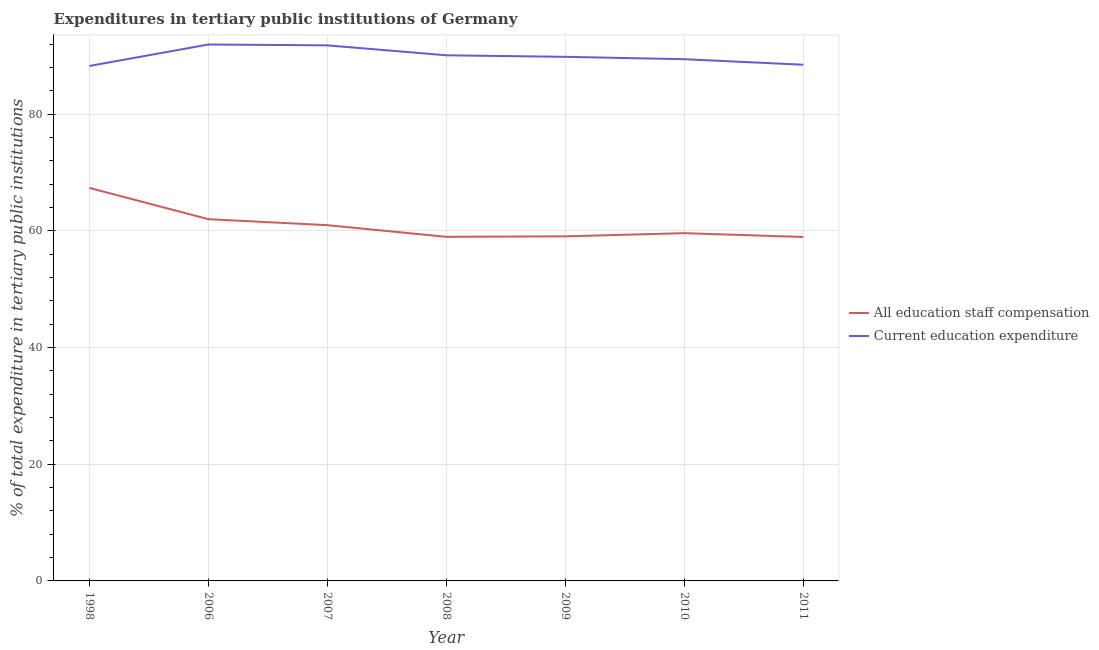Does the line corresponding to expenditure in staff compensation intersect with the line corresponding to expenditure in education?
Your response must be concise. No. Is the number of lines equal to the number of legend labels?
Your answer should be compact. Yes. What is the expenditure in education in 1998?
Make the answer very short. 88.29. Across all years, what is the maximum expenditure in staff compensation?
Give a very brief answer. 67.39. Across all years, what is the minimum expenditure in education?
Give a very brief answer. 88.29. In which year was the expenditure in education maximum?
Your answer should be compact. 2006. In which year was the expenditure in staff compensation minimum?
Offer a terse response. 2011. What is the total expenditure in education in the graph?
Ensure brevity in your answer.  630.03. What is the difference between the expenditure in education in 2006 and that in 2007?
Your answer should be very brief. 0.15. What is the difference between the expenditure in staff compensation in 2007 and the expenditure in education in 2006?
Your answer should be compact. -30.98. What is the average expenditure in staff compensation per year?
Offer a terse response. 61.01. In the year 2007, what is the difference between the expenditure in staff compensation and expenditure in education?
Your response must be concise. -30.83. In how many years, is the expenditure in education greater than 88 %?
Provide a succinct answer. 7. What is the ratio of the expenditure in education in 2006 to that in 2009?
Offer a very short reply. 1.02. Is the difference between the expenditure in staff compensation in 2007 and 2009 greater than the difference between the expenditure in education in 2007 and 2009?
Make the answer very short. No. What is the difference between the highest and the second highest expenditure in education?
Offer a terse response. 0.15. What is the difference between the highest and the lowest expenditure in staff compensation?
Offer a very short reply. 8.42. In how many years, is the expenditure in staff compensation greater than the average expenditure in staff compensation taken over all years?
Offer a terse response. 2. Does the expenditure in education monotonically increase over the years?
Offer a very short reply. No. Is the expenditure in staff compensation strictly greater than the expenditure in education over the years?
Make the answer very short. No. How many years are there in the graph?
Your answer should be very brief. 7. Are the values on the major ticks of Y-axis written in scientific E-notation?
Offer a terse response. No. Does the graph contain any zero values?
Give a very brief answer. No. Does the graph contain grids?
Keep it short and to the point. Yes. How many legend labels are there?
Provide a succinct answer. 2. What is the title of the graph?
Provide a short and direct response. Expenditures in tertiary public institutions of Germany. What is the label or title of the Y-axis?
Your answer should be very brief. % of total expenditure in tertiary public institutions. What is the % of total expenditure in tertiary public institutions in All education staff compensation in 1998?
Ensure brevity in your answer.  67.39. What is the % of total expenditure in tertiary public institutions of Current education expenditure in 1998?
Provide a succinct answer. 88.29. What is the % of total expenditure in tertiary public institutions in All education staff compensation in 2006?
Keep it short and to the point. 62.02. What is the % of total expenditure in tertiary public institutions in Current education expenditure in 2006?
Provide a succinct answer. 91.97. What is the % of total expenditure in tertiary public institutions of All education staff compensation in 2007?
Your answer should be very brief. 61. What is the % of total expenditure in tertiary public institutions of Current education expenditure in 2007?
Your answer should be compact. 91.83. What is the % of total expenditure in tertiary public institutions of All education staff compensation in 2008?
Ensure brevity in your answer.  59. What is the % of total expenditure in tertiary public institutions of Current education expenditure in 2008?
Your answer should be compact. 90.12. What is the % of total expenditure in tertiary public institutions in All education staff compensation in 2009?
Offer a terse response. 59.08. What is the % of total expenditure in tertiary public institutions of Current education expenditure in 2009?
Offer a very short reply. 89.86. What is the % of total expenditure in tertiary public institutions in All education staff compensation in 2010?
Your answer should be very brief. 59.63. What is the % of total expenditure in tertiary public institutions in Current education expenditure in 2010?
Offer a very short reply. 89.45. What is the % of total expenditure in tertiary public institutions of All education staff compensation in 2011?
Offer a terse response. 58.97. What is the % of total expenditure in tertiary public institutions of Current education expenditure in 2011?
Provide a succinct answer. 88.5. Across all years, what is the maximum % of total expenditure in tertiary public institutions in All education staff compensation?
Your answer should be very brief. 67.39. Across all years, what is the maximum % of total expenditure in tertiary public institutions of Current education expenditure?
Give a very brief answer. 91.97. Across all years, what is the minimum % of total expenditure in tertiary public institutions in All education staff compensation?
Your response must be concise. 58.97. Across all years, what is the minimum % of total expenditure in tertiary public institutions in Current education expenditure?
Offer a terse response. 88.29. What is the total % of total expenditure in tertiary public institutions of All education staff compensation in the graph?
Your response must be concise. 427.09. What is the total % of total expenditure in tertiary public institutions in Current education expenditure in the graph?
Your response must be concise. 630.03. What is the difference between the % of total expenditure in tertiary public institutions in All education staff compensation in 1998 and that in 2006?
Your response must be concise. 5.36. What is the difference between the % of total expenditure in tertiary public institutions in Current education expenditure in 1998 and that in 2006?
Offer a terse response. -3.68. What is the difference between the % of total expenditure in tertiary public institutions in All education staff compensation in 1998 and that in 2007?
Offer a terse response. 6.39. What is the difference between the % of total expenditure in tertiary public institutions in Current education expenditure in 1998 and that in 2007?
Make the answer very short. -3.53. What is the difference between the % of total expenditure in tertiary public institutions of All education staff compensation in 1998 and that in 2008?
Offer a terse response. 8.39. What is the difference between the % of total expenditure in tertiary public institutions in Current education expenditure in 1998 and that in 2008?
Keep it short and to the point. -1.83. What is the difference between the % of total expenditure in tertiary public institutions of All education staff compensation in 1998 and that in 2009?
Offer a terse response. 8.31. What is the difference between the % of total expenditure in tertiary public institutions of Current education expenditure in 1998 and that in 2009?
Your answer should be compact. -1.57. What is the difference between the % of total expenditure in tertiary public institutions of All education staff compensation in 1998 and that in 2010?
Make the answer very short. 7.76. What is the difference between the % of total expenditure in tertiary public institutions of Current education expenditure in 1998 and that in 2010?
Make the answer very short. -1.16. What is the difference between the % of total expenditure in tertiary public institutions of All education staff compensation in 1998 and that in 2011?
Offer a very short reply. 8.42. What is the difference between the % of total expenditure in tertiary public institutions in Current education expenditure in 1998 and that in 2011?
Your answer should be very brief. -0.21. What is the difference between the % of total expenditure in tertiary public institutions of All education staff compensation in 2006 and that in 2007?
Your response must be concise. 1.03. What is the difference between the % of total expenditure in tertiary public institutions of Current education expenditure in 2006 and that in 2007?
Give a very brief answer. 0.15. What is the difference between the % of total expenditure in tertiary public institutions of All education staff compensation in 2006 and that in 2008?
Your answer should be very brief. 3.03. What is the difference between the % of total expenditure in tertiary public institutions of Current education expenditure in 2006 and that in 2008?
Make the answer very short. 1.85. What is the difference between the % of total expenditure in tertiary public institutions in All education staff compensation in 2006 and that in 2009?
Offer a terse response. 2.94. What is the difference between the % of total expenditure in tertiary public institutions of Current education expenditure in 2006 and that in 2009?
Offer a very short reply. 2.11. What is the difference between the % of total expenditure in tertiary public institutions of All education staff compensation in 2006 and that in 2010?
Offer a very short reply. 2.4. What is the difference between the % of total expenditure in tertiary public institutions in Current education expenditure in 2006 and that in 2010?
Your response must be concise. 2.52. What is the difference between the % of total expenditure in tertiary public institutions of All education staff compensation in 2006 and that in 2011?
Provide a short and direct response. 3.05. What is the difference between the % of total expenditure in tertiary public institutions of Current education expenditure in 2006 and that in 2011?
Your answer should be very brief. 3.47. What is the difference between the % of total expenditure in tertiary public institutions in All education staff compensation in 2007 and that in 2008?
Offer a very short reply. 2. What is the difference between the % of total expenditure in tertiary public institutions in Current education expenditure in 2007 and that in 2008?
Offer a terse response. 1.7. What is the difference between the % of total expenditure in tertiary public institutions in All education staff compensation in 2007 and that in 2009?
Your response must be concise. 1.92. What is the difference between the % of total expenditure in tertiary public institutions in Current education expenditure in 2007 and that in 2009?
Keep it short and to the point. 1.97. What is the difference between the % of total expenditure in tertiary public institutions of All education staff compensation in 2007 and that in 2010?
Provide a short and direct response. 1.37. What is the difference between the % of total expenditure in tertiary public institutions of Current education expenditure in 2007 and that in 2010?
Provide a succinct answer. 2.37. What is the difference between the % of total expenditure in tertiary public institutions of All education staff compensation in 2007 and that in 2011?
Your answer should be very brief. 2.03. What is the difference between the % of total expenditure in tertiary public institutions of Current education expenditure in 2007 and that in 2011?
Your answer should be compact. 3.32. What is the difference between the % of total expenditure in tertiary public institutions in All education staff compensation in 2008 and that in 2009?
Provide a succinct answer. -0.08. What is the difference between the % of total expenditure in tertiary public institutions in Current education expenditure in 2008 and that in 2009?
Offer a terse response. 0.26. What is the difference between the % of total expenditure in tertiary public institutions of All education staff compensation in 2008 and that in 2010?
Keep it short and to the point. -0.63. What is the difference between the % of total expenditure in tertiary public institutions of Current education expenditure in 2008 and that in 2010?
Your answer should be very brief. 0.67. What is the difference between the % of total expenditure in tertiary public institutions in All education staff compensation in 2008 and that in 2011?
Make the answer very short. 0.03. What is the difference between the % of total expenditure in tertiary public institutions of Current education expenditure in 2008 and that in 2011?
Give a very brief answer. 1.62. What is the difference between the % of total expenditure in tertiary public institutions in All education staff compensation in 2009 and that in 2010?
Give a very brief answer. -0.54. What is the difference between the % of total expenditure in tertiary public institutions in Current education expenditure in 2009 and that in 2010?
Provide a short and direct response. 0.41. What is the difference between the % of total expenditure in tertiary public institutions in All education staff compensation in 2009 and that in 2011?
Provide a short and direct response. 0.11. What is the difference between the % of total expenditure in tertiary public institutions of Current education expenditure in 2009 and that in 2011?
Make the answer very short. 1.36. What is the difference between the % of total expenditure in tertiary public institutions in All education staff compensation in 2010 and that in 2011?
Offer a very short reply. 0.65. What is the difference between the % of total expenditure in tertiary public institutions in Current education expenditure in 2010 and that in 2011?
Provide a short and direct response. 0.95. What is the difference between the % of total expenditure in tertiary public institutions of All education staff compensation in 1998 and the % of total expenditure in tertiary public institutions of Current education expenditure in 2006?
Your answer should be compact. -24.58. What is the difference between the % of total expenditure in tertiary public institutions in All education staff compensation in 1998 and the % of total expenditure in tertiary public institutions in Current education expenditure in 2007?
Your answer should be very brief. -24.44. What is the difference between the % of total expenditure in tertiary public institutions of All education staff compensation in 1998 and the % of total expenditure in tertiary public institutions of Current education expenditure in 2008?
Your response must be concise. -22.73. What is the difference between the % of total expenditure in tertiary public institutions of All education staff compensation in 1998 and the % of total expenditure in tertiary public institutions of Current education expenditure in 2009?
Offer a very short reply. -22.47. What is the difference between the % of total expenditure in tertiary public institutions in All education staff compensation in 1998 and the % of total expenditure in tertiary public institutions in Current education expenditure in 2010?
Offer a very short reply. -22.06. What is the difference between the % of total expenditure in tertiary public institutions in All education staff compensation in 1998 and the % of total expenditure in tertiary public institutions in Current education expenditure in 2011?
Provide a succinct answer. -21.11. What is the difference between the % of total expenditure in tertiary public institutions of All education staff compensation in 2006 and the % of total expenditure in tertiary public institutions of Current education expenditure in 2007?
Give a very brief answer. -29.8. What is the difference between the % of total expenditure in tertiary public institutions in All education staff compensation in 2006 and the % of total expenditure in tertiary public institutions in Current education expenditure in 2008?
Make the answer very short. -28.1. What is the difference between the % of total expenditure in tertiary public institutions of All education staff compensation in 2006 and the % of total expenditure in tertiary public institutions of Current education expenditure in 2009?
Ensure brevity in your answer.  -27.83. What is the difference between the % of total expenditure in tertiary public institutions of All education staff compensation in 2006 and the % of total expenditure in tertiary public institutions of Current education expenditure in 2010?
Provide a succinct answer. -27.43. What is the difference between the % of total expenditure in tertiary public institutions in All education staff compensation in 2006 and the % of total expenditure in tertiary public institutions in Current education expenditure in 2011?
Make the answer very short. -26.48. What is the difference between the % of total expenditure in tertiary public institutions in All education staff compensation in 2007 and the % of total expenditure in tertiary public institutions in Current education expenditure in 2008?
Keep it short and to the point. -29.13. What is the difference between the % of total expenditure in tertiary public institutions in All education staff compensation in 2007 and the % of total expenditure in tertiary public institutions in Current education expenditure in 2009?
Your answer should be very brief. -28.86. What is the difference between the % of total expenditure in tertiary public institutions of All education staff compensation in 2007 and the % of total expenditure in tertiary public institutions of Current education expenditure in 2010?
Provide a short and direct response. -28.46. What is the difference between the % of total expenditure in tertiary public institutions of All education staff compensation in 2007 and the % of total expenditure in tertiary public institutions of Current education expenditure in 2011?
Your answer should be compact. -27.51. What is the difference between the % of total expenditure in tertiary public institutions of All education staff compensation in 2008 and the % of total expenditure in tertiary public institutions of Current education expenditure in 2009?
Make the answer very short. -30.86. What is the difference between the % of total expenditure in tertiary public institutions in All education staff compensation in 2008 and the % of total expenditure in tertiary public institutions in Current education expenditure in 2010?
Keep it short and to the point. -30.45. What is the difference between the % of total expenditure in tertiary public institutions of All education staff compensation in 2008 and the % of total expenditure in tertiary public institutions of Current education expenditure in 2011?
Your response must be concise. -29.5. What is the difference between the % of total expenditure in tertiary public institutions of All education staff compensation in 2009 and the % of total expenditure in tertiary public institutions of Current education expenditure in 2010?
Your response must be concise. -30.37. What is the difference between the % of total expenditure in tertiary public institutions in All education staff compensation in 2009 and the % of total expenditure in tertiary public institutions in Current education expenditure in 2011?
Ensure brevity in your answer.  -29.42. What is the difference between the % of total expenditure in tertiary public institutions in All education staff compensation in 2010 and the % of total expenditure in tertiary public institutions in Current education expenditure in 2011?
Ensure brevity in your answer.  -28.88. What is the average % of total expenditure in tertiary public institutions in All education staff compensation per year?
Your response must be concise. 61.01. What is the average % of total expenditure in tertiary public institutions of Current education expenditure per year?
Provide a succinct answer. 90. In the year 1998, what is the difference between the % of total expenditure in tertiary public institutions in All education staff compensation and % of total expenditure in tertiary public institutions in Current education expenditure?
Ensure brevity in your answer.  -20.9. In the year 2006, what is the difference between the % of total expenditure in tertiary public institutions of All education staff compensation and % of total expenditure in tertiary public institutions of Current education expenditure?
Your answer should be compact. -29.95. In the year 2007, what is the difference between the % of total expenditure in tertiary public institutions of All education staff compensation and % of total expenditure in tertiary public institutions of Current education expenditure?
Provide a short and direct response. -30.83. In the year 2008, what is the difference between the % of total expenditure in tertiary public institutions in All education staff compensation and % of total expenditure in tertiary public institutions in Current education expenditure?
Keep it short and to the point. -31.12. In the year 2009, what is the difference between the % of total expenditure in tertiary public institutions of All education staff compensation and % of total expenditure in tertiary public institutions of Current education expenditure?
Ensure brevity in your answer.  -30.78. In the year 2010, what is the difference between the % of total expenditure in tertiary public institutions in All education staff compensation and % of total expenditure in tertiary public institutions in Current education expenditure?
Provide a succinct answer. -29.83. In the year 2011, what is the difference between the % of total expenditure in tertiary public institutions in All education staff compensation and % of total expenditure in tertiary public institutions in Current education expenditure?
Offer a terse response. -29.53. What is the ratio of the % of total expenditure in tertiary public institutions of All education staff compensation in 1998 to that in 2006?
Keep it short and to the point. 1.09. What is the ratio of the % of total expenditure in tertiary public institutions of Current education expenditure in 1998 to that in 2006?
Your answer should be very brief. 0.96. What is the ratio of the % of total expenditure in tertiary public institutions in All education staff compensation in 1998 to that in 2007?
Make the answer very short. 1.1. What is the ratio of the % of total expenditure in tertiary public institutions of Current education expenditure in 1998 to that in 2007?
Make the answer very short. 0.96. What is the ratio of the % of total expenditure in tertiary public institutions in All education staff compensation in 1998 to that in 2008?
Provide a short and direct response. 1.14. What is the ratio of the % of total expenditure in tertiary public institutions in Current education expenditure in 1998 to that in 2008?
Your answer should be very brief. 0.98. What is the ratio of the % of total expenditure in tertiary public institutions in All education staff compensation in 1998 to that in 2009?
Make the answer very short. 1.14. What is the ratio of the % of total expenditure in tertiary public institutions of Current education expenditure in 1998 to that in 2009?
Your answer should be compact. 0.98. What is the ratio of the % of total expenditure in tertiary public institutions in All education staff compensation in 1998 to that in 2010?
Ensure brevity in your answer.  1.13. What is the ratio of the % of total expenditure in tertiary public institutions of Current education expenditure in 1998 to that in 2010?
Your answer should be compact. 0.99. What is the ratio of the % of total expenditure in tertiary public institutions in All education staff compensation in 1998 to that in 2011?
Provide a short and direct response. 1.14. What is the ratio of the % of total expenditure in tertiary public institutions in All education staff compensation in 2006 to that in 2007?
Offer a terse response. 1.02. What is the ratio of the % of total expenditure in tertiary public institutions in Current education expenditure in 2006 to that in 2007?
Ensure brevity in your answer.  1. What is the ratio of the % of total expenditure in tertiary public institutions in All education staff compensation in 2006 to that in 2008?
Ensure brevity in your answer.  1.05. What is the ratio of the % of total expenditure in tertiary public institutions of Current education expenditure in 2006 to that in 2008?
Your answer should be compact. 1.02. What is the ratio of the % of total expenditure in tertiary public institutions in All education staff compensation in 2006 to that in 2009?
Provide a short and direct response. 1.05. What is the ratio of the % of total expenditure in tertiary public institutions in Current education expenditure in 2006 to that in 2009?
Offer a terse response. 1.02. What is the ratio of the % of total expenditure in tertiary public institutions in All education staff compensation in 2006 to that in 2010?
Offer a very short reply. 1.04. What is the ratio of the % of total expenditure in tertiary public institutions of Current education expenditure in 2006 to that in 2010?
Offer a terse response. 1.03. What is the ratio of the % of total expenditure in tertiary public institutions in All education staff compensation in 2006 to that in 2011?
Keep it short and to the point. 1.05. What is the ratio of the % of total expenditure in tertiary public institutions of Current education expenditure in 2006 to that in 2011?
Keep it short and to the point. 1.04. What is the ratio of the % of total expenditure in tertiary public institutions in All education staff compensation in 2007 to that in 2008?
Provide a succinct answer. 1.03. What is the ratio of the % of total expenditure in tertiary public institutions of Current education expenditure in 2007 to that in 2008?
Offer a terse response. 1.02. What is the ratio of the % of total expenditure in tertiary public institutions in All education staff compensation in 2007 to that in 2009?
Ensure brevity in your answer.  1.03. What is the ratio of the % of total expenditure in tertiary public institutions of Current education expenditure in 2007 to that in 2009?
Offer a terse response. 1.02. What is the ratio of the % of total expenditure in tertiary public institutions in All education staff compensation in 2007 to that in 2010?
Offer a terse response. 1.02. What is the ratio of the % of total expenditure in tertiary public institutions in Current education expenditure in 2007 to that in 2010?
Your answer should be compact. 1.03. What is the ratio of the % of total expenditure in tertiary public institutions in All education staff compensation in 2007 to that in 2011?
Provide a succinct answer. 1.03. What is the ratio of the % of total expenditure in tertiary public institutions of Current education expenditure in 2007 to that in 2011?
Provide a short and direct response. 1.04. What is the ratio of the % of total expenditure in tertiary public institutions of All education staff compensation in 2008 to that in 2009?
Give a very brief answer. 1. What is the ratio of the % of total expenditure in tertiary public institutions of Current education expenditure in 2008 to that in 2010?
Your answer should be compact. 1.01. What is the ratio of the % of total expenditure in tertiary public institutions of Current education expenditure in 2008 to that in 2011?
Provide a succinct answer. 1.02. What is the ratio of the % of total expenditure in tertiary public institutions in All education staff compensation in 2009 to that in 2010?
Make the answer very short. 0.99. What is the ratio of the % of total expenditure in tertiary public institutions of Current education expenditure in 2009 to that in 2011?
Your response must be concise. 1.02. What is the ratio of the % of total expenditure in tertiary public institutions of All education staff compensation in 2010 to that in 2011?
Your answer should be compact. 1.01. What is the ratio of the % of total expenditure in tertiary public institutions in Current education expenditure in 2010 to that in 2011?
Make the answer very short. 1.01. What is the difference between the highest and the second highest % of total expenditure in tertiary public institutions in All education staff compensation?
Your answer should be very brief. 5.36. What is the difference between the highest and the second highest % of total expenditure in tertiary public institutions of Current education expenditure?
Ensure brevity in your answer.  0.15. What is the difference between the highest and the lowest % of total expenditure in tertiary public institutions of All education staff compensation?
Your response must be concise. 8.42. What is the difference between the highest and the lowest % of total expenditure in tertiary public institutions of Current education expenditure?
Offer a terse response. 3.68. 